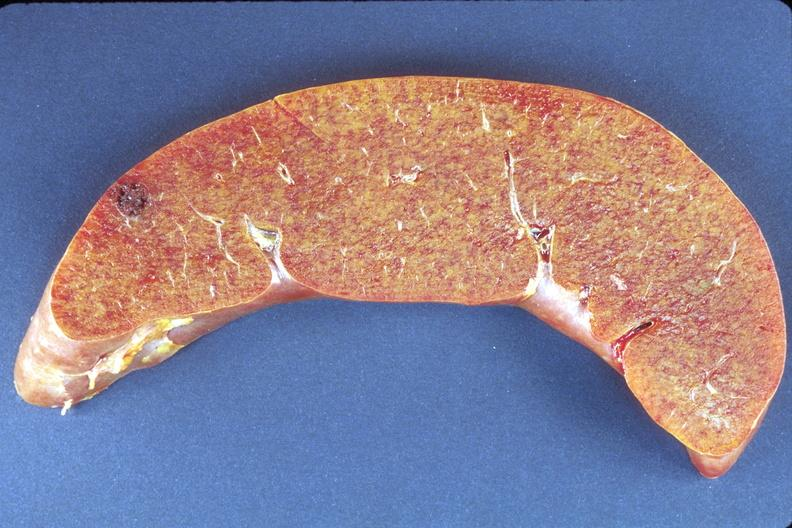does this image show liver, amyloidosis?
Answer the question using a single word or phrase. Yes 